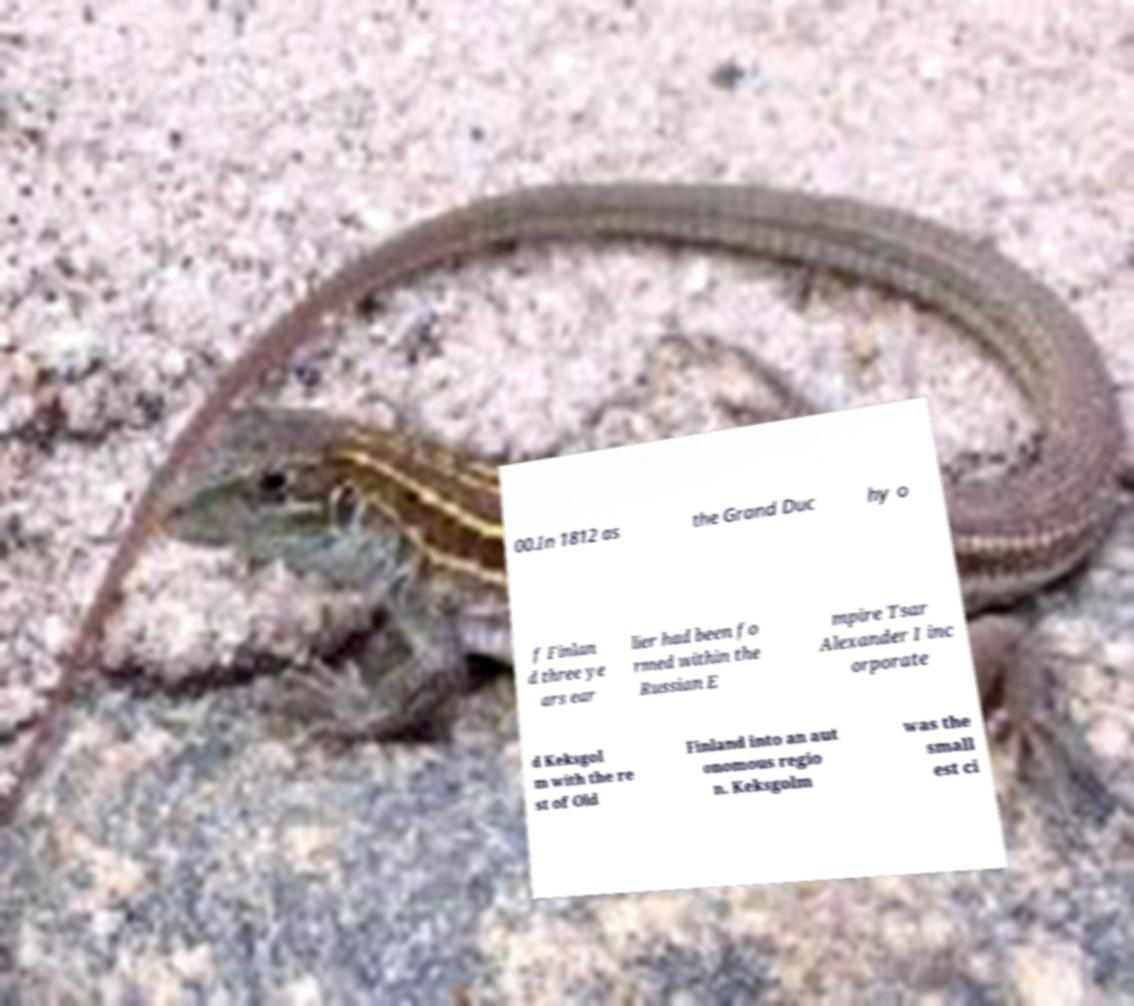For documentation purposes, I need the text within this image transcribed. Could you provide that? 00.In 1812 as the Grand Duc hy o f Finlan d three ye ars ear lier had been fo rmed within the Russian E mpire Tsar Alexander I inc orporate d Keksgol m with the re st of Old Finland into an aut onomous regio n. Keksgolm was the small est ci 